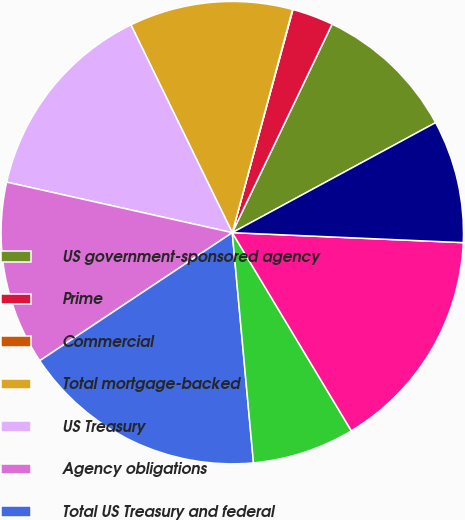<chart> <loc_0><loc_0><loc_500><loc_500><pie_chart><fcel>US government-sponsored agency<fcel>Prime<fcel>Commercial<fcel>Total mortgage-backed<fcel>US Treasury<fcel>Agency obligations<fcel>Total US Treasury and federal<fcel>State and municipal<fcel>Foreign government<fcel>Corporate<nl><fcel>10.0%<fcel>2.88%<fcel>0.03%<fcel>11.42%<fcel>14.27%<fcel>12.85%<fcel>17.12%<fcel>7.15%<fcel>15.7%<fcel>8.58%<nl></chart> 